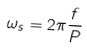Convert formula to latex. <formula><loc_0><loc_0><loc_500><loc_500>\omega _ { s } = 2 \pi \frac { f } { P }</formula> 